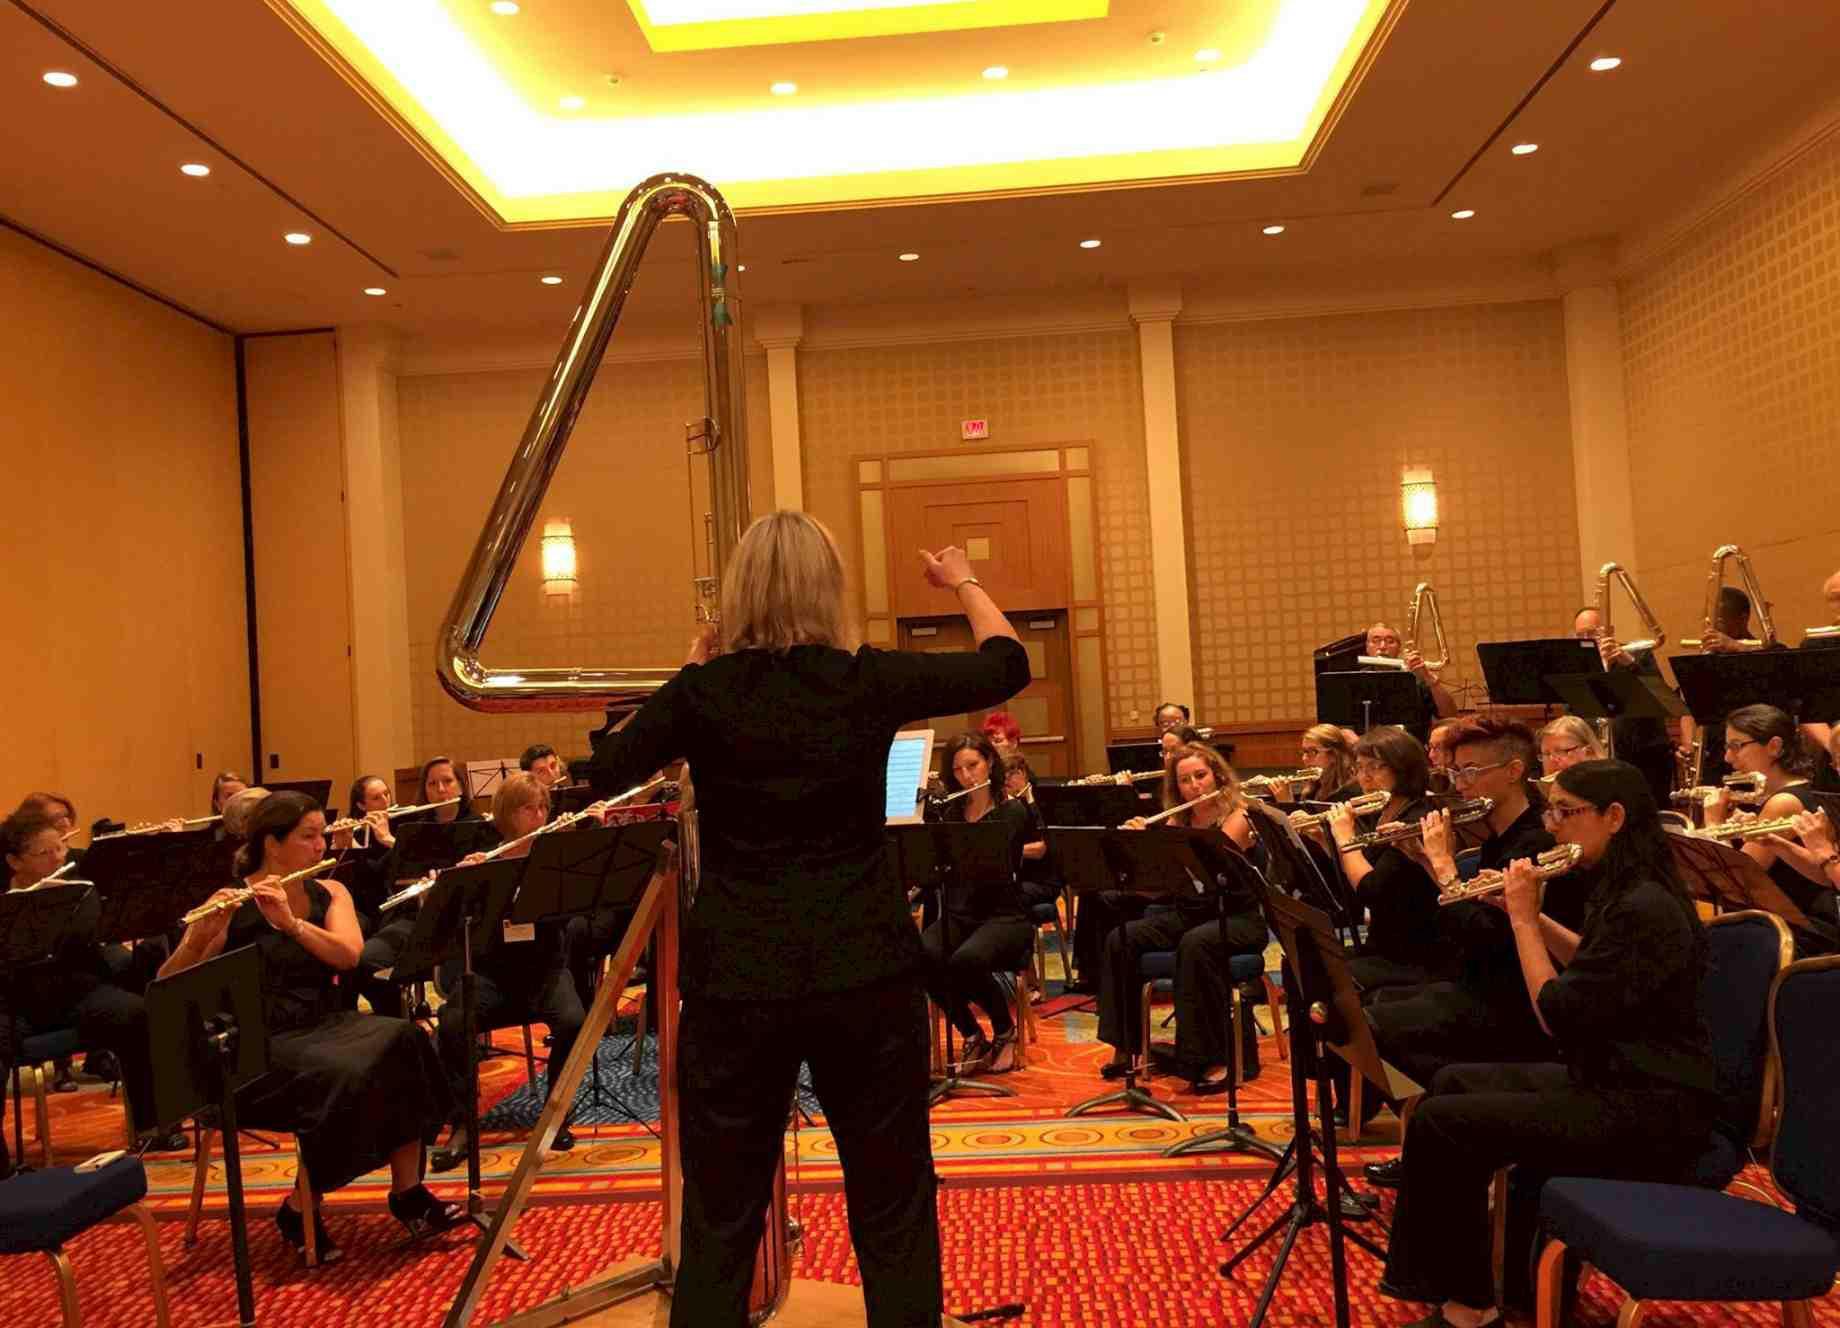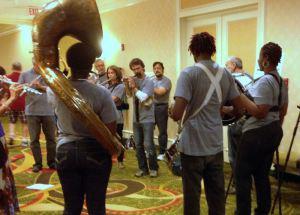The first image is the image on the left, the second image is the image on the right. Analyze the images presented: Is the assertion "Several musicians in black pose for a picture with their instruments in one of the images." valid? Answer yes or no. No. The first image is the image on the left, the second image is the image on the right. For the images shown, is this caption "The left image shows at least one row of mostly women facing forward, dressed in black, and holding an instrument but not playing it." true? Answer yes or no. No. 